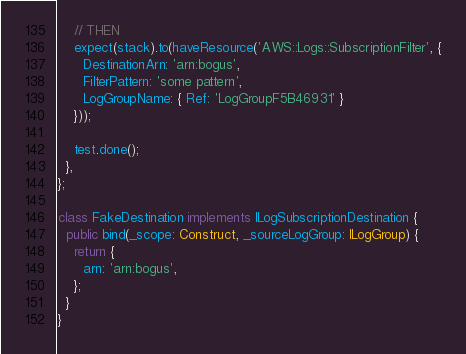<code> <loc_0><loc_0><loc_500><loc_500><_TypeScript_>    // THEN
    expect(stack).to(haveResource('AWS::Logs::SubscriptionFilter', {
      DestinationArn: 'arn:bogus',
      FilterPattern: 'some pattern',
      LogGroupName: { Ref: 'LogGroupF5B46931' }
    }));

    test.done();
  },
};

class FakeDestination implements ILogSubscriptionDestination {
  public bind(_scope: Construct, _sourceLogGroup: ILogGroup) {
    return {
      arn: 'arn:bogus',
    };
  }
}
</code> 